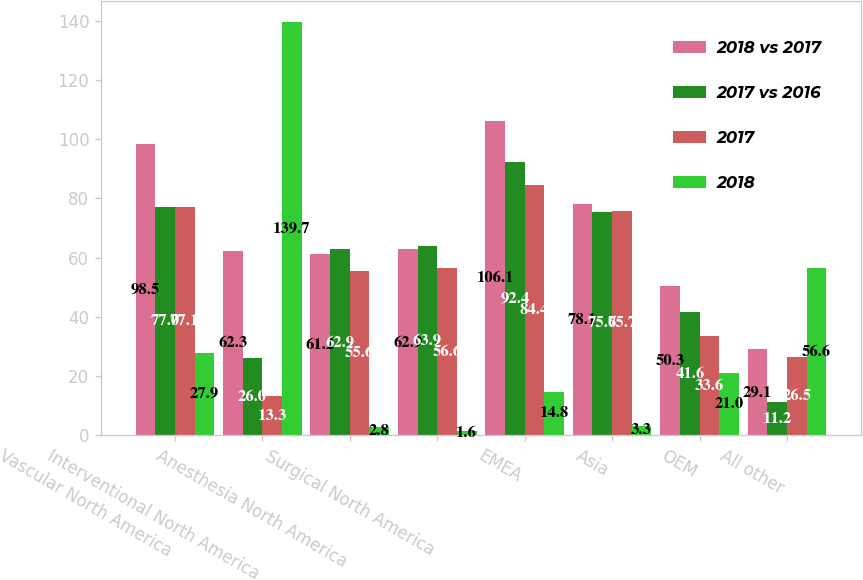<chart> <loc_0><loc_0><loc_500><loc_500><stacked_bar_chart><ecel><fcel>Vascular North America<fcel>Interventional North America<fcel>Anesthesia North America<fcel>Surgical North America<fcel>EMEA<fcel>Asia<fcel>OEM<fcel>All other<nl><fcel>2018 vs 2017<fcel>98.5<fcel>62.3<fcel>61.2<fcel>62.9<fcel>106.1<fcel>78.1<fcel>50.3<fcel>29.1<nl><fcel>2017 vs 2016<fcel>77<fcel>26<fcel>62.9<fcel>63.9<fcel>92.4<fcel>75.6<fcel>41.6<fcel>11.2<nl><fcel>2017<fcel>77.1<fcel>13.3<fcel>55.6<fcel>56.6<fcel>84.4<fcel>75.7<fcel>33.6<fcel>26.5<nl><fcel>2018<fcel>27.9<fcel>139.7<fcel>2.8<fcel>1.6<fcel>14.8<fcel>3.3<fcel>21<fcel>56.6<nl></chart> 